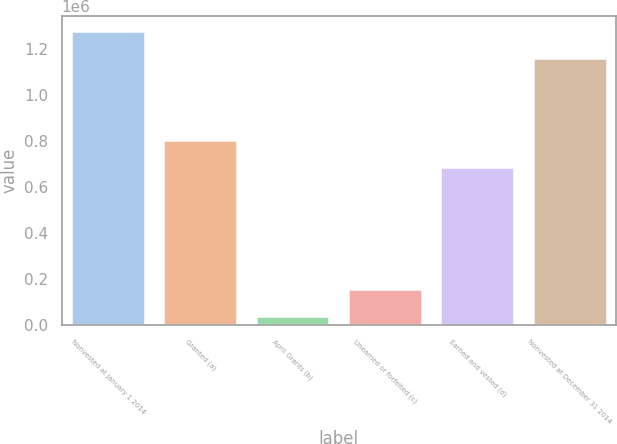Convert chart. <chart><loc_0><loc_0><loc_500><loc_500><bar_chart><fcel>Nonvested at January 1 2014<fcel>Granted (a)<fcel>April Grants (b)<fcel>Unearned or forfeited (c)<fcel>Earned and vested (d)<fcel>Nonvested at December 31 2014<nl><fcel>1.28038e+06<fcel>803616<fcel>38559<fcel>156558<fcel>685617<fcel>1.16238e+06<nl></chart> 